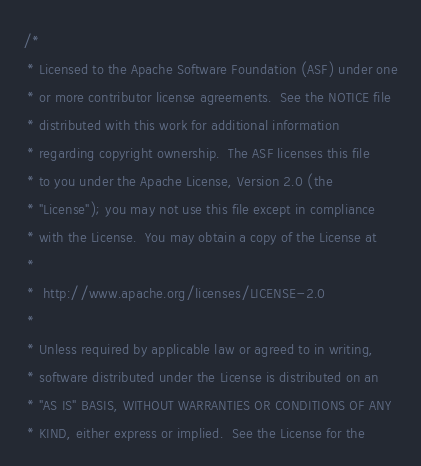Convert code to text. <code><loc_0><loc_0><loc_500><loc_500><_C_>/*
 * Licensed to the Apache Software Foundation (ASF) under one
 * or more contributor license agreements.  See the NOTICE file
 * distributed with this work for additional information
 * regarding copyright ownership.  The ASF licenses this file
 * to you under the Apache License, Version 2.0 (the
 * "License"); you may not use this file except in compliance
 * with the License.  You may obtain a copy of the License at
 *
 *  http://www.apache.org/licenses/LICENSE-2.0
 *
 * Unless required by applicable law or agreed to in writing,
 * software distributed under the License is distributed on an
 * "AS IS" BASIS, WITHOUT WARRANTIES OR CONDITIONS OF ANY
 * KIND, either express or implied.  See the License for the</code> 